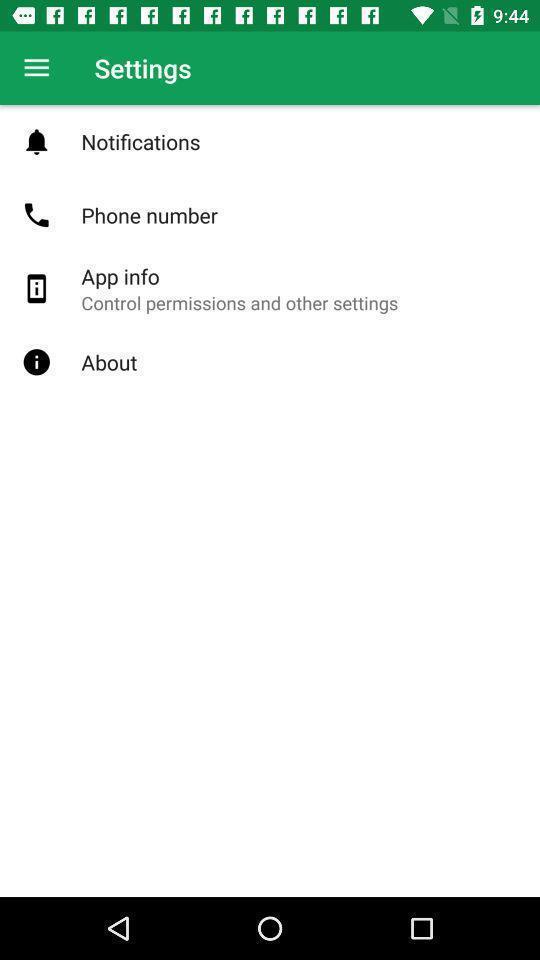Tell me what you see in this picture. Settings of the application with different options. 